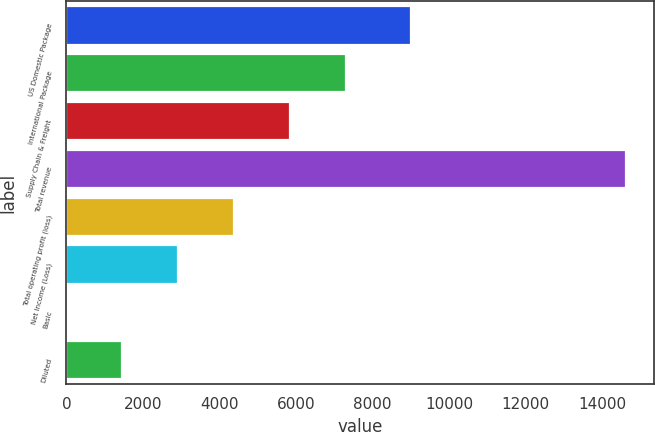<chart> <loc_0><loc_0><loc_500><loc_500><bar_chart><fcel>US Domestic Package<fcel>International Package<fcel>Supply Chain & Freight<fcel>Total revenue<fcel>Total operating profit (loss)<fcel>Net Income (Loss)<fcel>Basic<fcel>Diluted<nl><fcel>9015<fcel>7315.23<fcel>5852.47<fcel>14629<fcel>4389.71<fcel>2926.95<fcel>1.43<fcel>1464.19<nl></chart> 